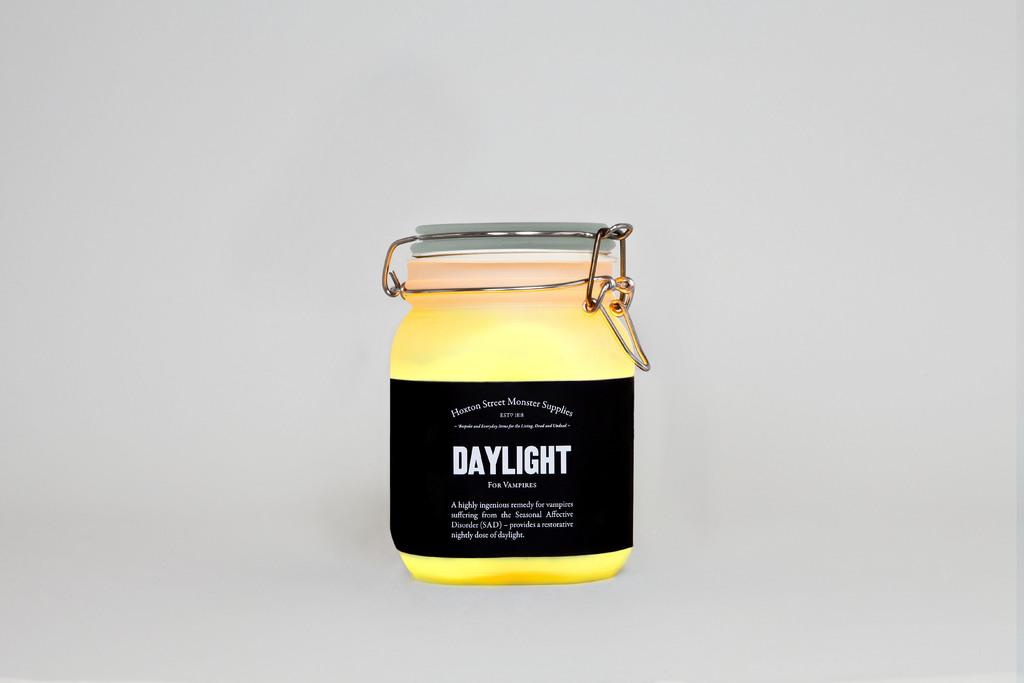<image>
Describe the image concisely. A jar with a wire buckle type lid fastener with a black label containing Daylight for vampires. 